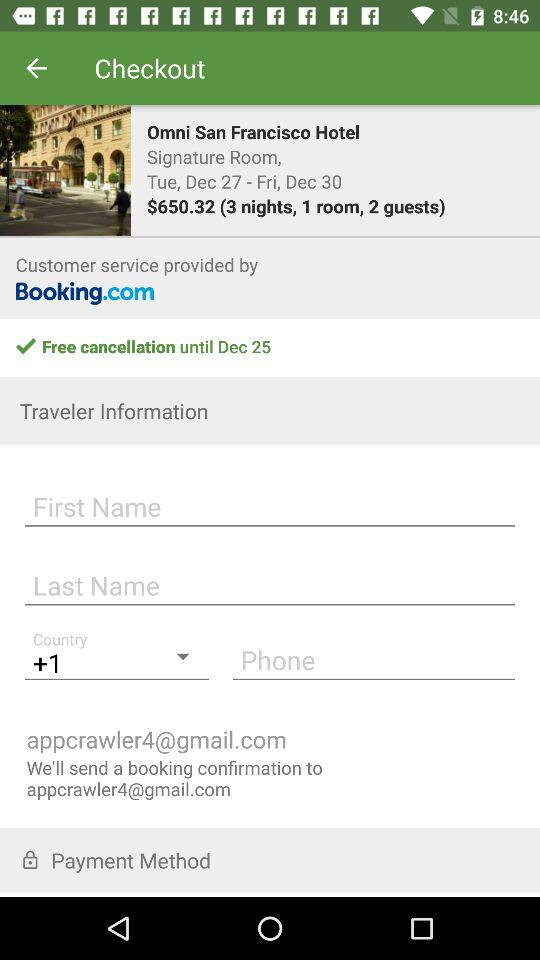What is the room category? The room category is signature. 